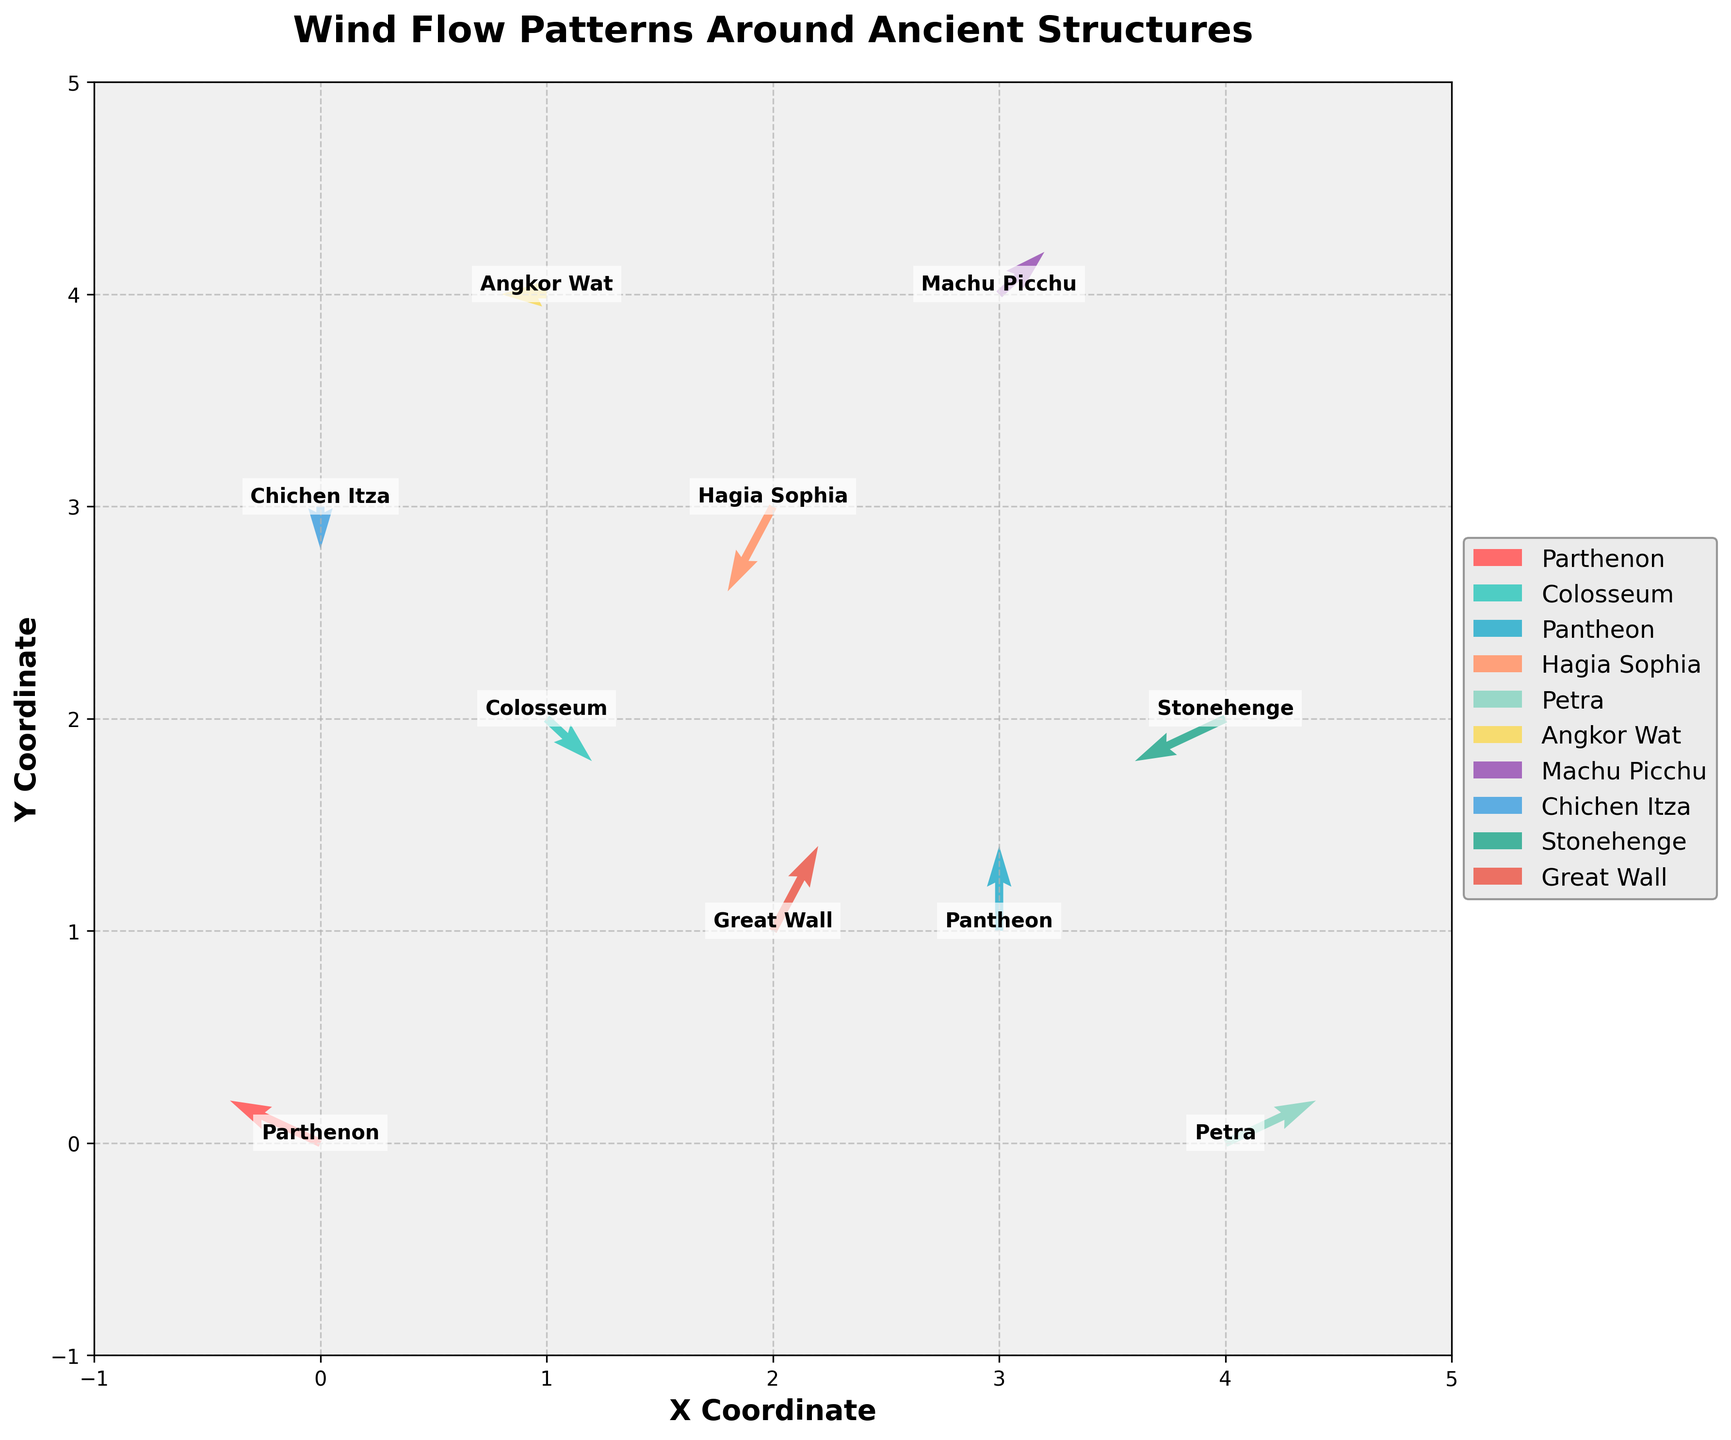What's the title of the figure? The title is usually found at the top of the figure and describes what the figure is about. In this case, it reads 'Wind Flow Patterns Around Ancient Structures'.
Answer: Wind Flow Patterns Around Ancient Structures How many different ancient structures are depicted in the figure? By looking at the legend or different labels in the figure, we can count the number of unique structures. There are 10 different labeled structures with distinct colors in the legend.
Answer: 10 Which structure has a wind flow pattern that moves directly upward? By examining the direction of arrows for each structure, the Machu Picchu has an arrow pointing more directly upward.
Answer: Machu Picchu Are there any structures where the wind flow pattern has no horizontal component? This requires identifying arrows that only have vertical components (u=0). In examining the plot, the structures Pantheon and Chichen Itza have arrows strictly moving vertically up or down.
Answer: Pantheon, Chichen Itza How does the wind flow pattern for the Parthenon compare to that of Petra? Compare the direction and magnitude of the arrows for both structures. Parthenon's wind is flowing left upward (-2, 1) while Petra's wind is flowing rightward (2, 1).
Answer: The Parthenon's wind flows left upward, while Petra's wind flows rightward Which structure has the strongest wind (highest combined magnitude of wind components)? Calculate the wind magnitude for each structure using the formula √(u² + v²). For example, Parthenon's magnitude is √((-2)² + 1²) = √5. Identify the structure with the largest magnitude. The Great Wall has the highest magnitude since √(1² + 2²) = √5 which is greater than any other.
Answer: Great Wall What is the horizontal range covered by the structures? Look at the x-axis range from the plot and list the minimum and maximum x-coordinates of all data points. The x-coordinates range from 0 to 4.
Answer: 0 to 4 What is the vertical range covered by the structures? Look at the y-axis range from the plot and list the minimum and maximum y-coordinates of all data points. The y-coordinates range from 0 to 4.
Answer: 0 to 4 Which structure has a wind flow pattern that is identical in direction to Angkor Wat? Compare the wind flow vectors (u, v) of all structures to Angkor Wat's vector (-1, 0). Only Angkor Wat has this specific direction vector, no other structure shares this vector.
Answer: None 